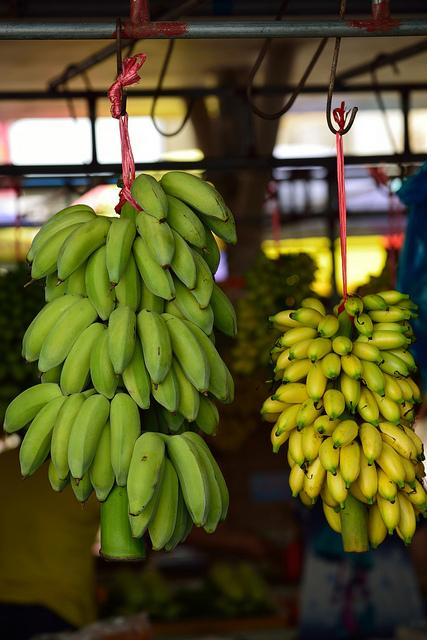Where are these items sold? Please explain your reasoning. shoprite. These items are bananas, not pieces of lumber, electronic devices, or pieces of fabric. 